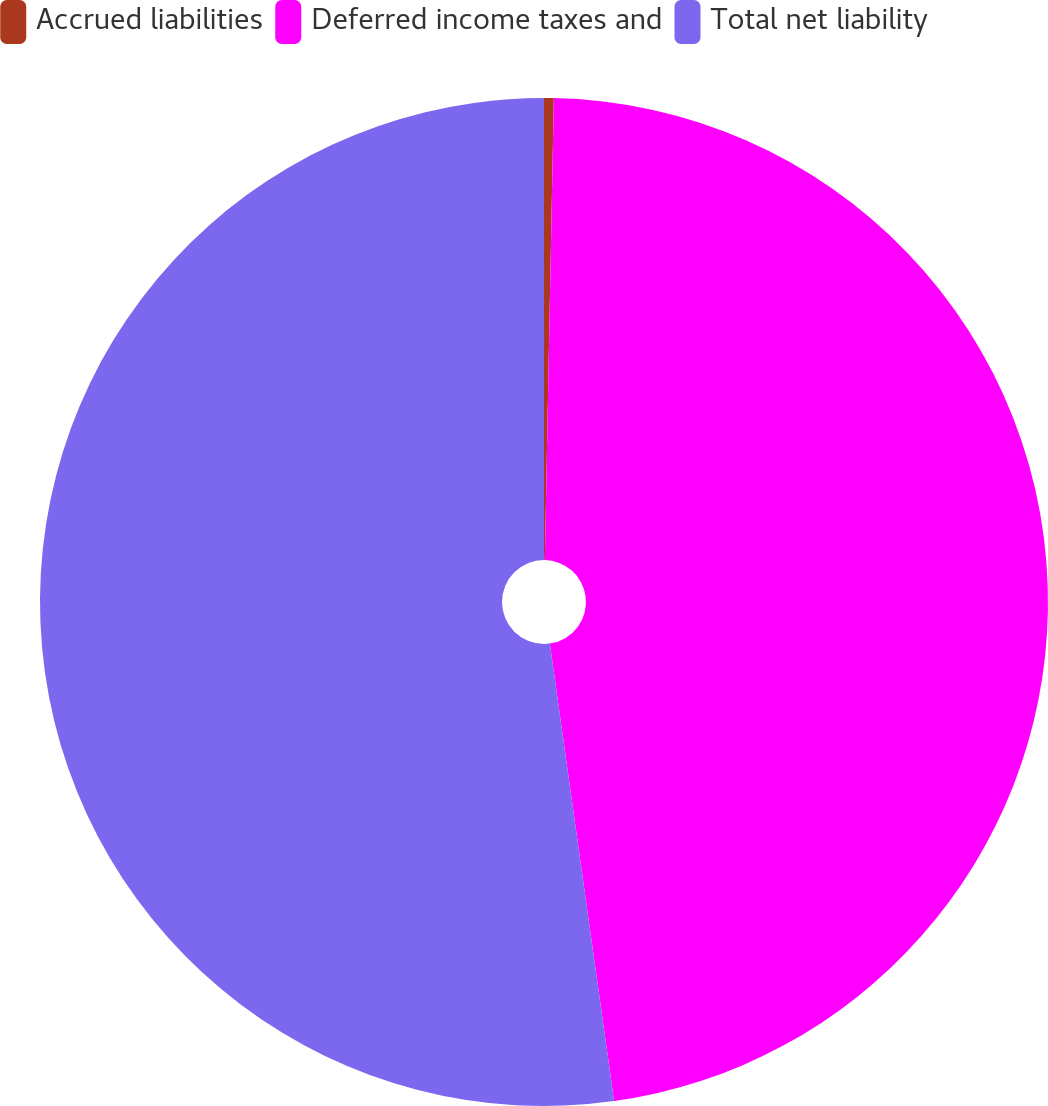Convert chart. <chart><loc_0><loc_0><loc_500><loc_500><pie_chart><fcel>Accrued liabilities<fcel>Deferred income taxes and<fcel>Total net liability<nl><fcel>0.31%<fcel>47.47%<fcel>52.22%<nl></chart> 